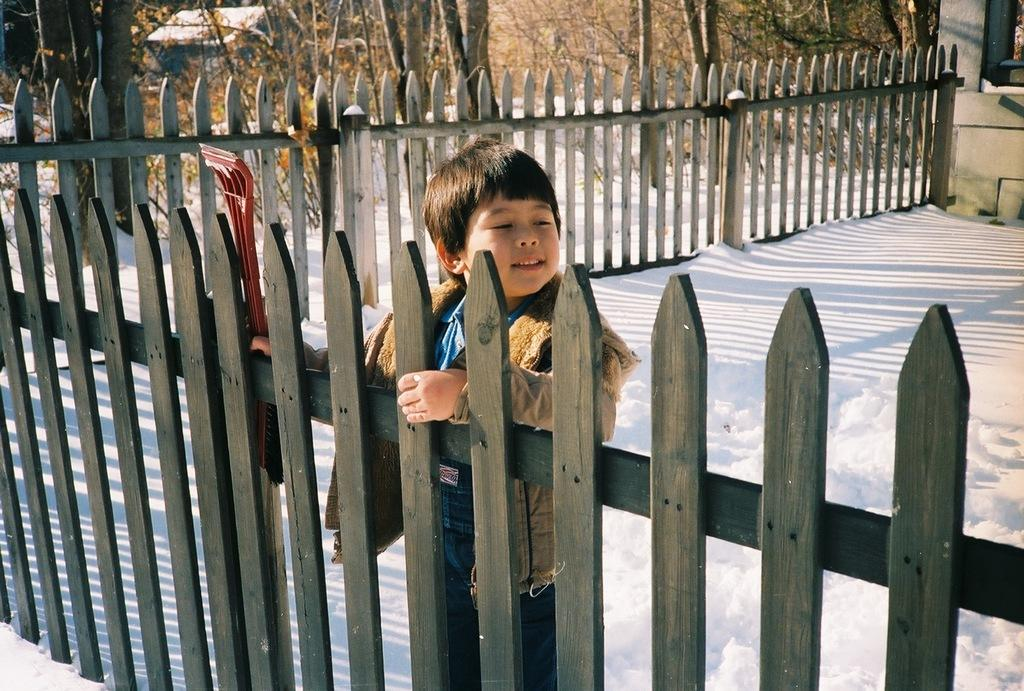What is the main subject of the image? There is a child in the image. What is the child wearing? The child is wearing a sweater. Where is the child standing in relation to the fence? The child is standing near a wooden fence. What can be seen in the background of the image? There is a road covered with snow, wooden houses, and trees visible in the background. What type of drug can be seen in the child's hand in the image? There is no drug present in the image; the child is not holding anything in their hand. 